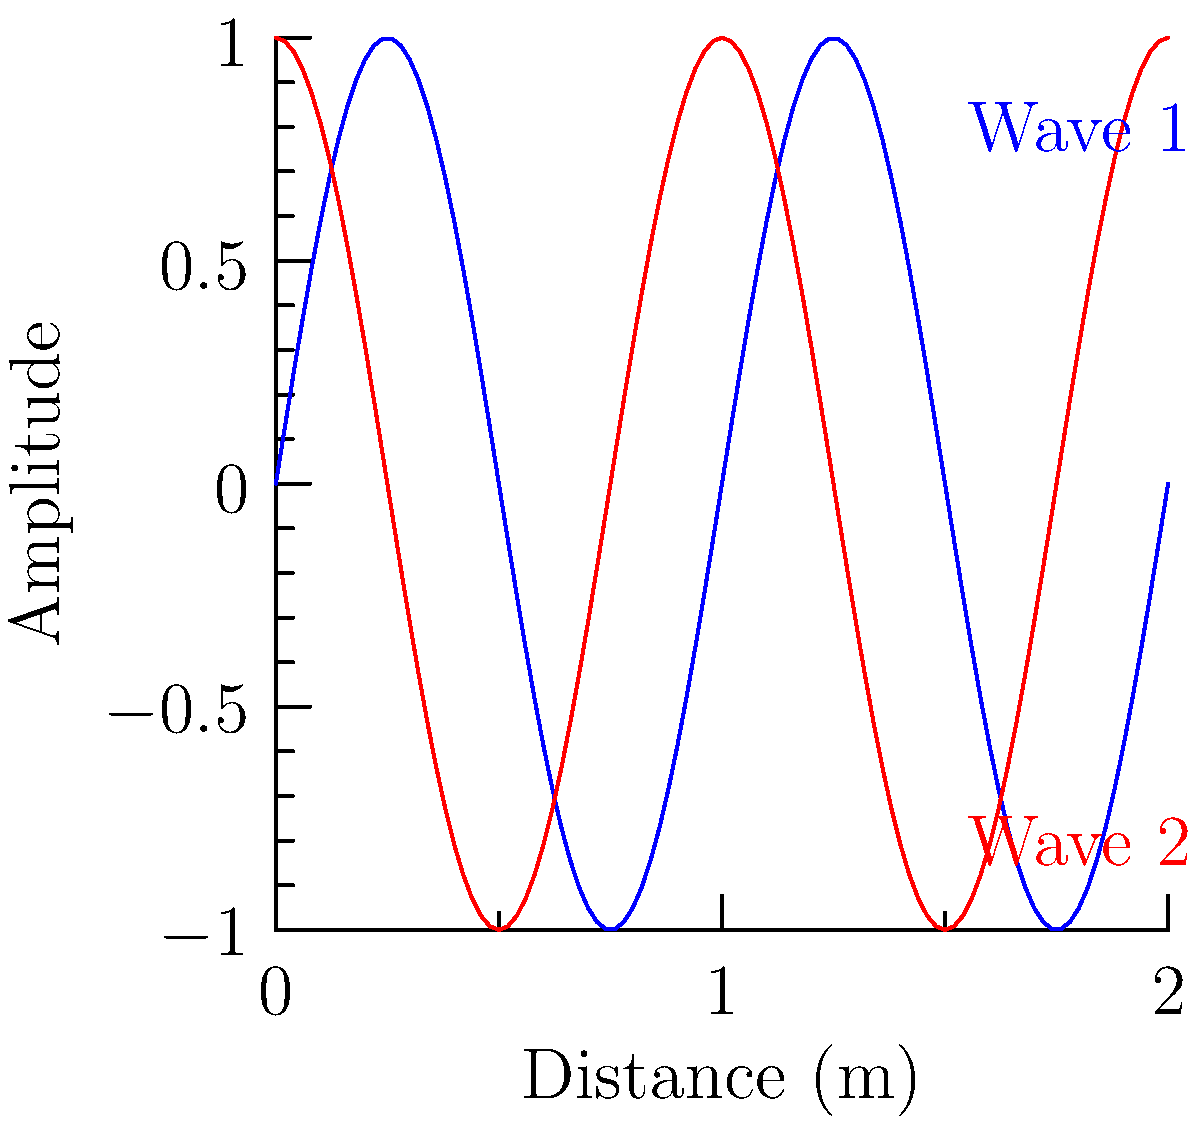In a rectangular venue, two identical speakers are placed at opposite ends, each emitting a pure tone with a frequency of 440 Hz. The graph shows the sound waves from each speaker along the center line of the venue. At what distances from the left speaker will constructive interference occur, assuming the speed of sound is 343 m/s? To solve this problem, we need to follow these steps:

1. Calculate the wavelength of the sound:
   $$\lambda = \frac{v}{f} = \frac{343 \text{ m/s}}{440 \text{ Hz}} = 0.78 \text{ m}$$

2. Identify the phase difference between the two waves:
   From the graph, we can see that the red wave (Wave 2) is shifted by 1/4 of a wavelength (π/2 radians) compared to the blue wave (Wave 1).

3. Determine the condition for constructive interference:
   Constructive interference occurs when the path difference is an integer multiple of the wavelength, accounting for the initial phase difference:
   $$\Delta x = n\lambda - \frac{\lambda}{4}, \text{ where } n = 0, 1, 2, ...$$

4. Calculate the distances for constructive interference:
   For n = 0: $$x = 0 - \frac{0.78}{4} = -0.195 \text{ m}$$
   For n = 1: $$x = 0.78 - \frac{0.78}{4} = 0.585 \text{ m}$$
   For n = 2: $$x = 1.56 - \frac{0.78}{4} = 1.365 \text{ m}$$
   And so on...

5. Discard negative values and values greater than the venue length.

Therefore, constructive interference will occur at approximately 0.585 m, 1.365 m, and at subsequent intervals of 0.78 m from the left speaker, until reaching the right speaker.
Answer: 0.585 m, 1.365 m, and every 0.78 m thereafter 